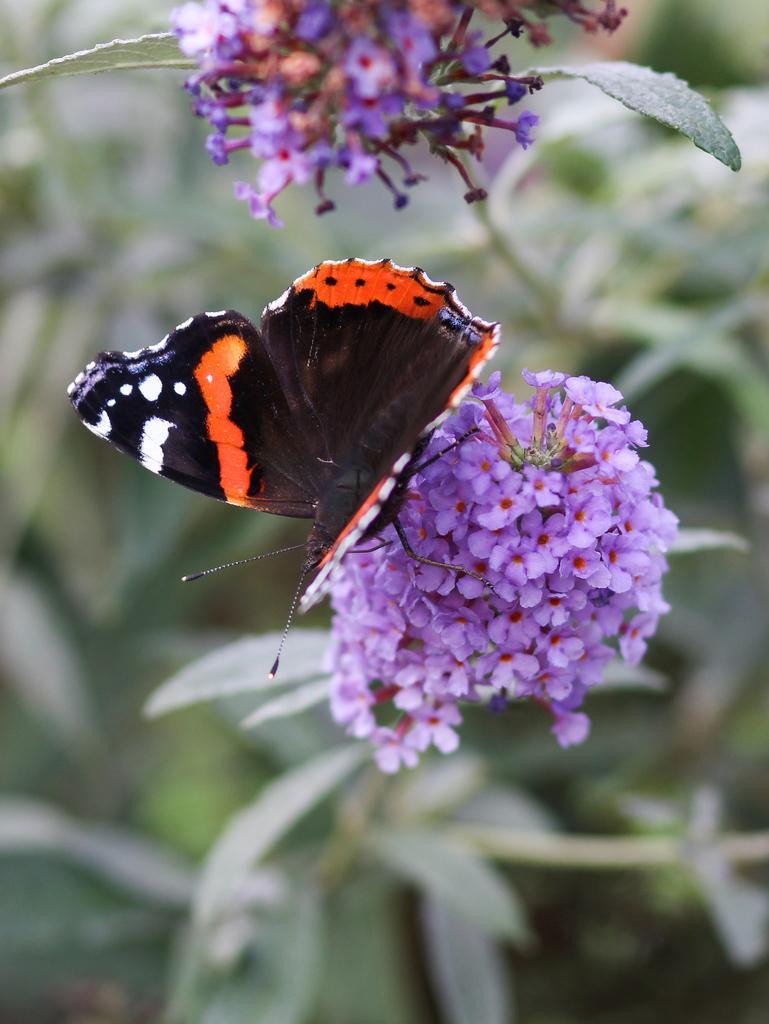How would you summarize this image in a sentence or two? It is a zoom in picture of a butterfly on the flower to the plant. 